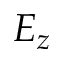<formula> <loc_0><loc_0><loc_500><loc_500>E _ { z }</formula> 